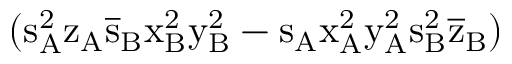Convert formula to latex. <formula><loc_0><loc_0><loc_500><loc_500>( s _ { A } ^ { 2 } \mathrm { z _ { A } \mathrm { \overline { s } _ { B } \mathrm { x _ { B } ^ { 2 } \mathrm { y _ { B } ^ { 2 } - \mathrm { s _ { A } \mathrm { x _ { A } ^ { 2 } \mathrm { y _ { A } ^ { 2 } \mathrm { s _ { B } ^ { 2 } \mathrm { \overline { z } _ { B } ) } } } } } } } } }</formula> 